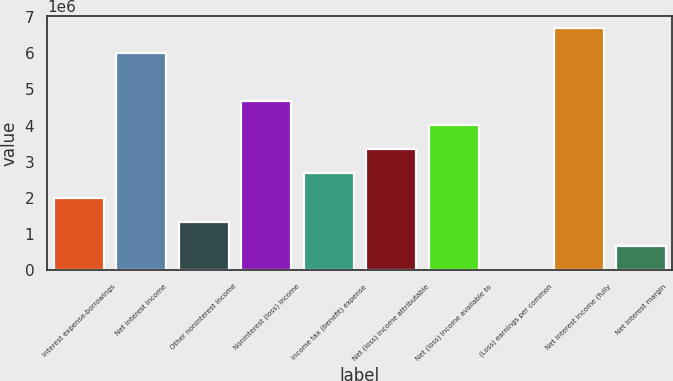Convert chart. <chart><loc_0><loc_0><loc_500><loc_500><bar_chart><fcel>Interest expense-borrowings<fcel>Net interest income<fcel>Other noninterest income<fcel>Noninterest (loss) income<fcel>Income tax (benefit) expense<fcel>Net (loss) income attributable<fcel>Net (loss) income available to<fcel>(Loss) earnings per common<fcel>Net interest income (fully<fcel>Net interest margin<nl><fcel>2.00774e+06<fcel>6.02321e+06<fcel>1.33849e+06<fcel>4.68472e+06<fcel>2.67698e+06<fcel>3.34623e+06<fcel>4.01547e+06<fcel>3.37<fcel>6.69246e+06<fcel>669249<nl></chart> 